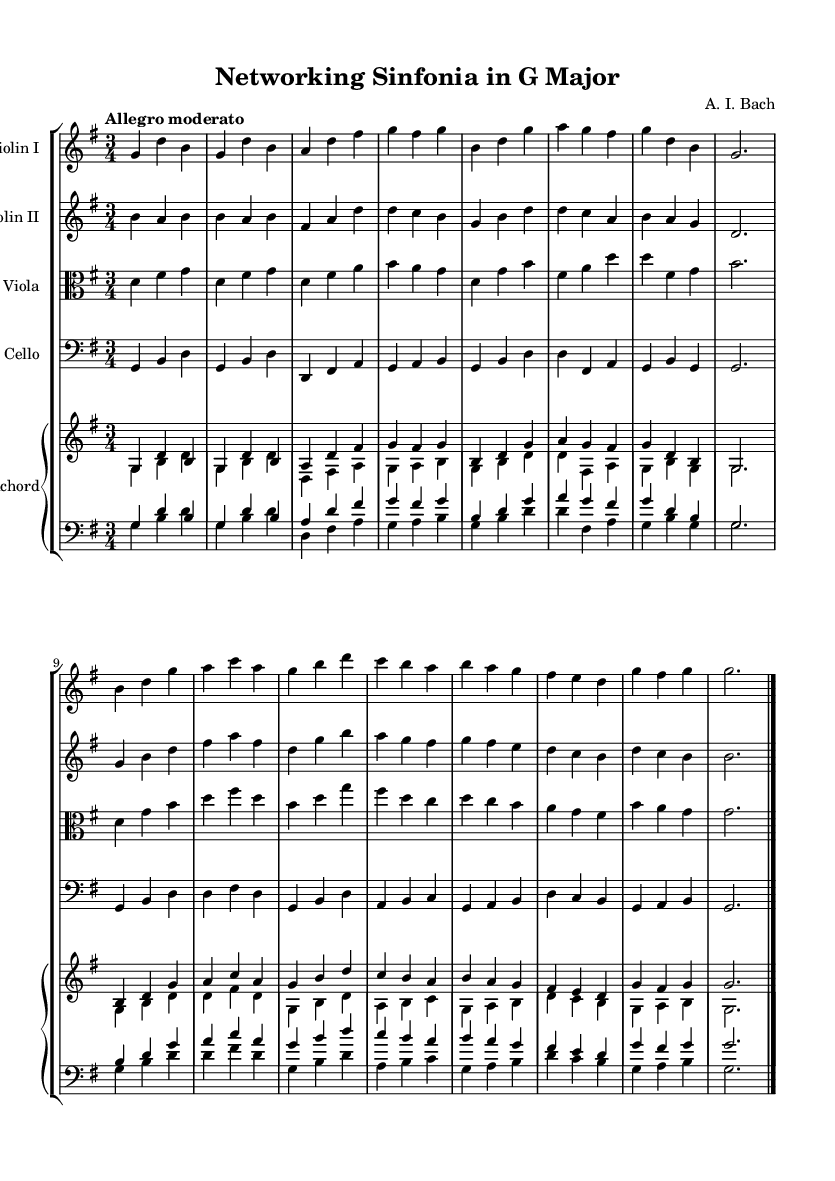What is the key signature of this music? The key signature is indicated at the beginning of the staff. In this case, there is one sharp, which signifies that the piece is in G major.
Answer: G major What is the time signature of this piece? The time signature is located at the beginning of the staff. Here, it shows three beats per measure, indicated by the 3/4, meaning each measure has three quarter note beats.
Answer: 3/4 What is the tempo marking for this composition? The tempo marking is denoted at the beginning, indicating the speed of the composition. In this score, it states "Allegro moderato," suggesting a moderate fast tempo.
Answer: Allegro moderato How many instrumental parts are there in this orchestral suite? By looking at the score, there are five distinct instrumental parts: Violin I, Violin II, Viola, Cello, and Harpsichord.
Answer: Five What is the predominant mood or style reflective of the Baroque period in this music? By analyzing the rhythmic patterns and the ornamentation typical of the Baroque style, one can determine that the piece exudes a lively and joyful mood, appropriate for ceremonial occasions.
Answer: Lively Which instruments are playing the main thematic material in this section? In Baroque orchestral suites, typically strings like violins carry themes. In this composition, the principal thematic material is handled by the violins, with harmonies from the viola and cello complementing them.
Answer: Violins What is the function of the harpsichord in this orchestral suite? The harpsichord primarily serves as a continuo instrument in Baroque music, providing harmonic support and embellishments throughout the piece, as seen in the score where it plays alongside the strings.
Answer: Continuo instrument 